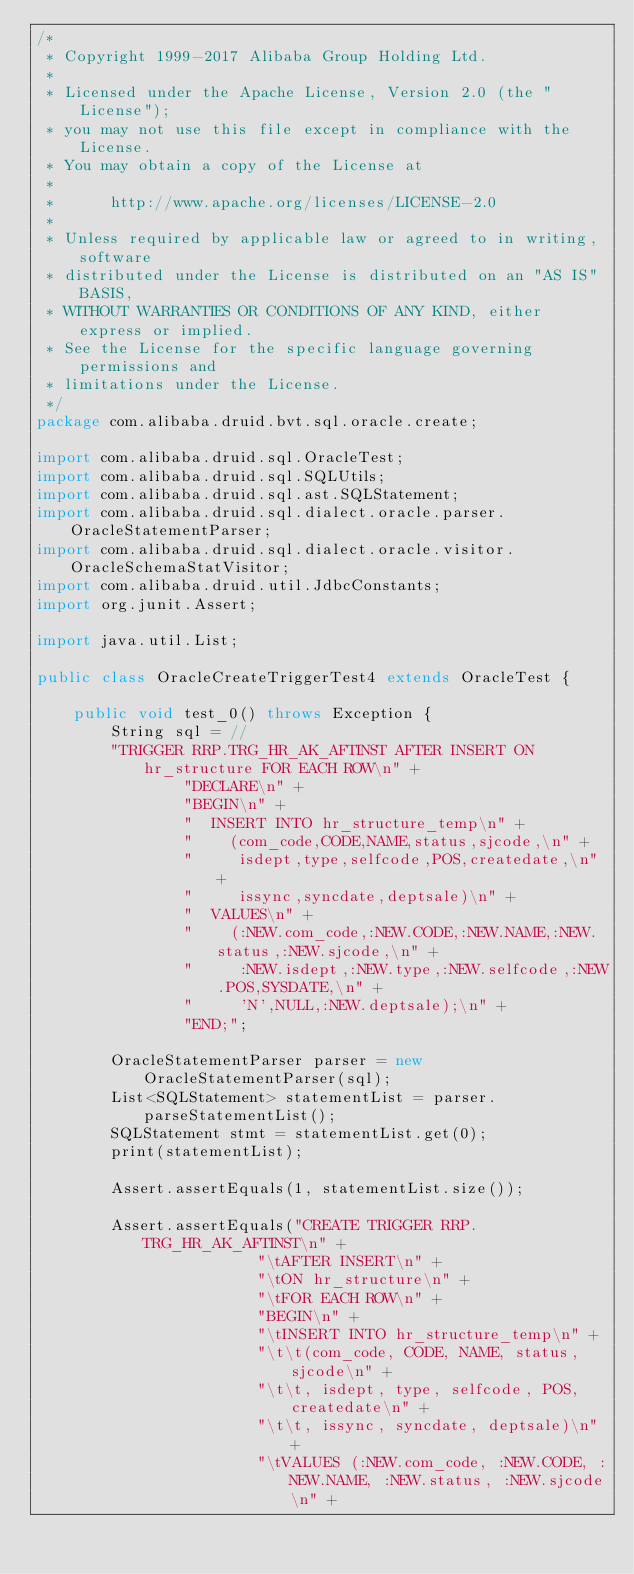Convert code to text. <code><loc_0><loc_0><loc_500><loc_500><_Java_>/*
 * Copyright 1999-2017 Alibaba Group Holding Ltd.
 *
 * Licensed under the Apache License, Version 2.0 (the "License");
 * you may not use this file except in compliance with the License.
 * You may obtain a copy of the License at
 *
 *      http://www.apache.org/licenses/LICENSE-2.0
 *
 * Unless required by applicable law or agreed to in writing, software
 * distributed under the License is distributed on an "AS IS" BASIS,
 * WITHOUT WARRANTIES OR CONDITIONS OF ANY KIND, either express or implied.
 * See the License for the specific language governing permissions and
 * limitations under the License.
 */
package com.alibaba.druid.bvt.sql.oracle.create;

import com.alibaba.druid.sql.OracleTest;
import com.alibaba.druid.sql.SQLUtils;
import com.alibaba.druid.sql.ast.SQLStatement;
import com.alibaba.druid.sql.dialect.oracle.parser.OracleStatementParser;
import com.alibaba.druid.sql.dialect.oracle.visitor.OracleSchemaStatVisitor;
import com.alibaba.druid.util.JdbcConstants;
import org.junit.Assert;

import java.util.List;

public class OracleCreateTriggerTest4 extends OracleTest {

    public void test_0() throws Exception {
        String sql = //
        "TRIGGER RRP.TRG_HR_AK_AFTINST AFTER INSERT ON hr_structure FOR EACH ROW\n" +
                "DECLARE\n" +
                "BEGIN\n" +
                "  INSERT INTO hr_structure_temp\n" +
                "    (com_code,CODE,NAME,status,sjcode,\n" +
                "     isdept,type,selfcode,POS,createdate,\n" +
                "     issync,syncdate,deptsale)\n" +
                "  VALUES\n" +
                "    (:NEW.com_code,:NEW.CODE,:NEW.NAME,:NEW.status,:NEW.sjcode,\n" +
                "     :NEW.isdept,:NEW.type,:NEW.selfcode,:NEW.POS,SYSDATE,\n" +
                "     'N',NULL,:NEW.deptsale);\n" +
                "END;";

        OracleStatementParser parser = new OracleStatementParser(sql);
        List<SQLStatement> statementList = parser.parseStatementList();
        SQLStatement stmt = statementList.get(0);
        print(statementList);

        Assert.assertEquals(1, statementList.size());

        Assert.assertEquals("CREATE TRIGGER RRP.TRG_HR_AK_AFTINST\n" +
                        "\tAFTER INSERT\n" +
                        "\tON hr_structure\n" +
                        "\tFOR EACH ROW\n" +
                        "BEGIN\n" +
                        "\tINSERT INTO hr_structure_temp\n" +
                        "\t\t(com_code, CODE, NAME, status, sjcode\n" +
                        "\t\t, isdept, type, selfcode, POS, createdate\n" +
                        "\t\t, issync, syncdate, deptsale)\n" +
                        "\tVALUES (:NEW.com_code, :NEW.CODE, :NEW.NAME, :NEW.status, :NEW.sjcode\n" +</code> 